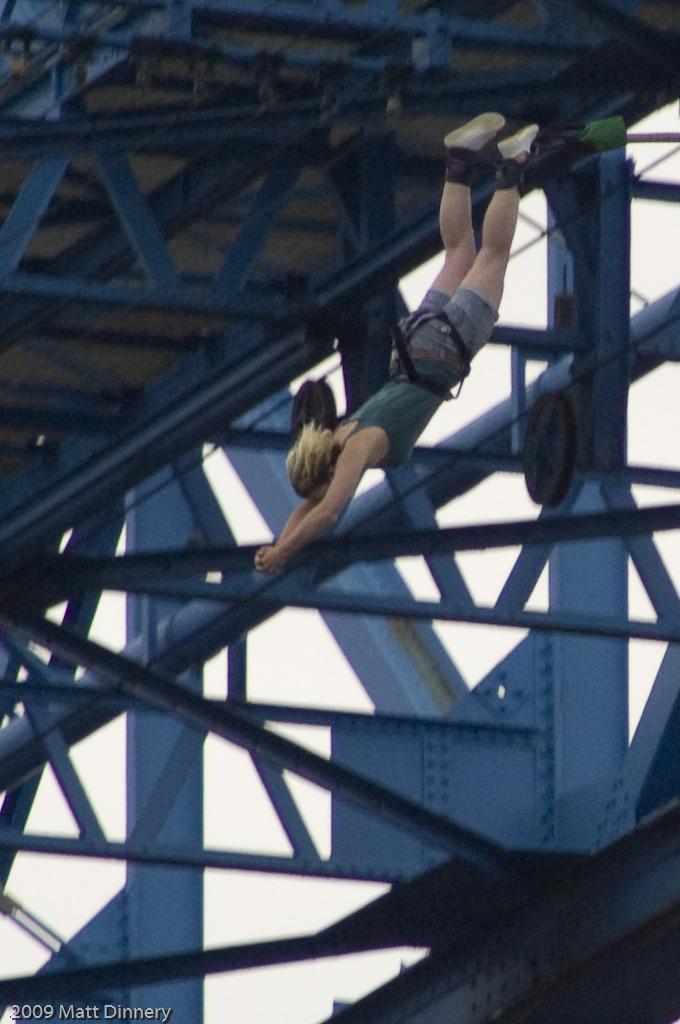Please provide a concise description of this image. This picture shows a bungee jump by a woman and we see a bridge and a cloudy sky. 